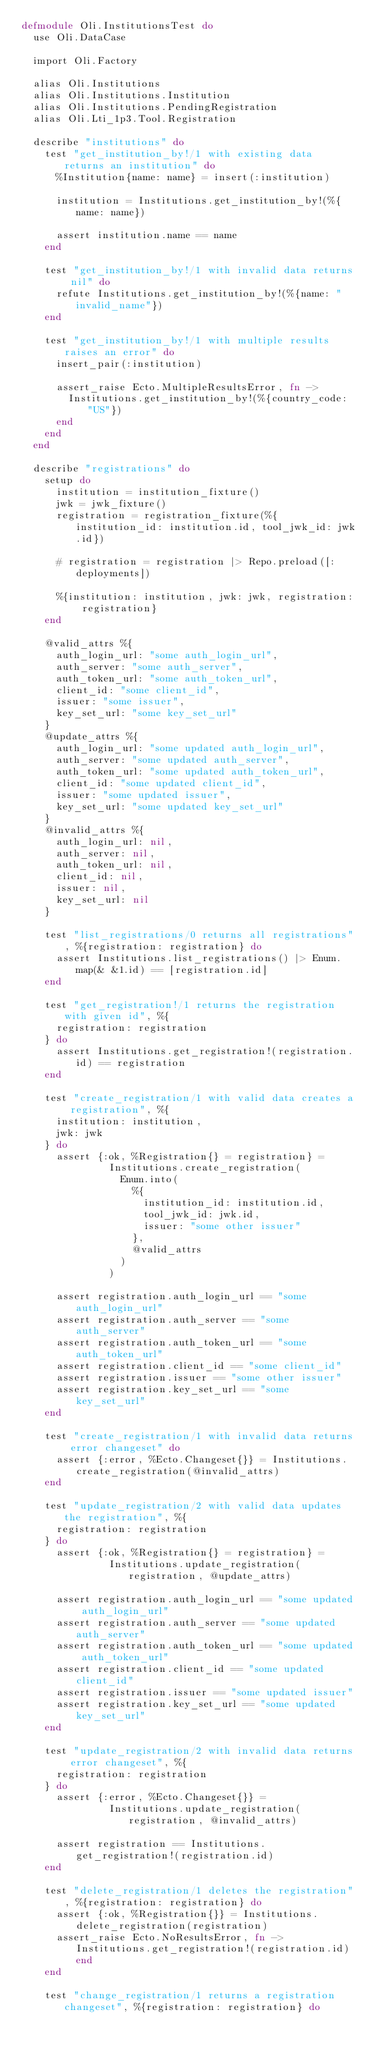Convert code to text. <code><loc_0><loc_0><loc_500><loc_500><_Elixir_>defmodule Oli.InstitutionsTest do
  use Oli.DataCase

  import Oli.Factory

  alias Oli.Institutions
  alias Oli.Institutions.Institution
  alias Oli.Institutions.PendingRegistration
  alias Oli.Lti_1p3.Tool.Registration

  describe "institutions" do
    test "get_institution_by!/1 with existing data returns an institution" do
      %Institution{name: name} = insert(:institution)

      institution = Institutions.get_institution_by!(%{name: name})

      assert institution.name == name
    end

    test "get_institution_by!/1 with invalid data returns nil" do
      refute Institutions.get_institution_by!(%{name: "invalid_name"})
    end

    test "get_institution_by!/1 with multiple results raises an error" do
      insert_pair(:institution)

      assert_raise Ecto.MultipleResultsError, fn ->
        Institutions.get_institution_by!(%{country_code: "US"})
      end
    end
  end

  describe "registrations" do
    setup do
      institution = institution_fixture()
      jwk = jwk_fixture()
      registration = registration_fixture(%{institution_id: institution.id, tool_jwk_id: jwk.id})

      # registration = registration |> Repo.preload([:deployments])

      %{institution: institution, jwk: jwk, registration: registration}
    end

    @valid_attrs %{
      auth_login_url: "some auth_login_url",
      auth_server: "some auth_server",
      auth_token_url: "some auth_token_url",
      client_id: "some client_id",
      issuer: "some issuer",
      key_set_url: "some key_set_url"
    }
    @update_attrs %{
      auth_login_url: "some updated auth_login_url",
      auth_server: "some updated auth_server",
      auth_token_url: "some updated auth_token_url",
      client_id: "some updated client_id",
      issuer: "some updated issuer",
      key_set_url: "some updated key_set_url"
    }
    @invalid_attrs %{
      auth_login_url: nil,
      auth_server: nil,
      auth_token_url: nil,
      client_id: nil,
      issuer: nil,
      key_set_url: nil
    }

    test "list_registrations/0 returns all registrations", %{registration: registration} do
      assert Institutions.list_registrations() |> Enum.map(& &1.id) == [registration.id]
    end

    test "get_registration!/1 returns the registration with given id", %{
      registration: registration
    } do
      assert Institutions.get_registration!(registration.id) == registration
    end

    test "create_registration/1 with valid data creates a registration", %{
      institution: institution,
      jwk: jwk
    } do
      assert {:ok, %Registration{} = registration} =
               Institutions.create_registration(
                 Enum.into(
                   %{
                     institution_id: institution.id,
                     tool_jwk_id: jwk.id,
                     issuer: "some other issuer"
                   },
                   @valid_attrs
                 )
               )

      assert registration.auth_login_url == "some auth_login_url"
      assert registration.auth_server == "some auth_server"
      assert registration.auth_token_url == "some auth_token_url"
      assert registration.client_id == "some client_id"
      assert registration.issuer == "some other issuer"
      assert registration.key_set_url == "some key_set_url"
    end

    test "create_registration/1 with invalid data returns error changeset" do
      assert {:error, %Ecto.Changeset{}} = Institutions.create_registration(@invalid_attrs)
    end

    test "update_registration/2 with valid data updates the registration", %{
      registration: registration
    } do
      assert {:ok, %Registration{} = registration} =
               Institutions.update_registration(registration, @update_attrs)

      assert registration.auth_login_url == "some updated auth_login_url"
      assert registration.auth_server == "some updated auth_server"
      assert registration.auth_token_url == "some updated auth_token_url"
      assert registration.client_id == "some updated client_id"
      assert registration.issuer == "some updated issuer"
      assert registration.key_set_url == "some updated key_set_url"
    end

    test "update_registration/2 with invalid data returns error changeset", %{
      registration: registration
    } do
      assert {:error, %Ecto.Changeset{}} =
               Institutions.update_registration(registration, @invalid_attrs)

      assert registration == Institutions.get_registration!(registration.id)
    end

    test "delete_registration/1 deletes the registration", %{registration: registration} do
      assert {:ok, %Registration{}} = Institutions.delete_registration(registration)
      assert_raise Ecto.NoResultsError, fn -> Institutions.get_registration!(registration.id) end
    end

    test "change_registration/1 returns a registration changeset", %{registration: registration} do</code> 